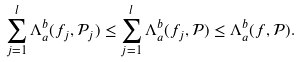<formula> <loc_0><loc_0><loc_500><loc_500>\sum _ { j = 1 } ^ { l } \Lambda _ { a } ^ { b } ( f _ { j } , \mathcal { P } _ { j } ) \leq \sum _ { j = 1 } ^ { l } \Lambda _ { a } ^ { b } ( f _ { j } , \mathcal { P } ) \leq \Lambda _ { a } ^ { b } ( f , \mathcal { P } ) .</formula> 